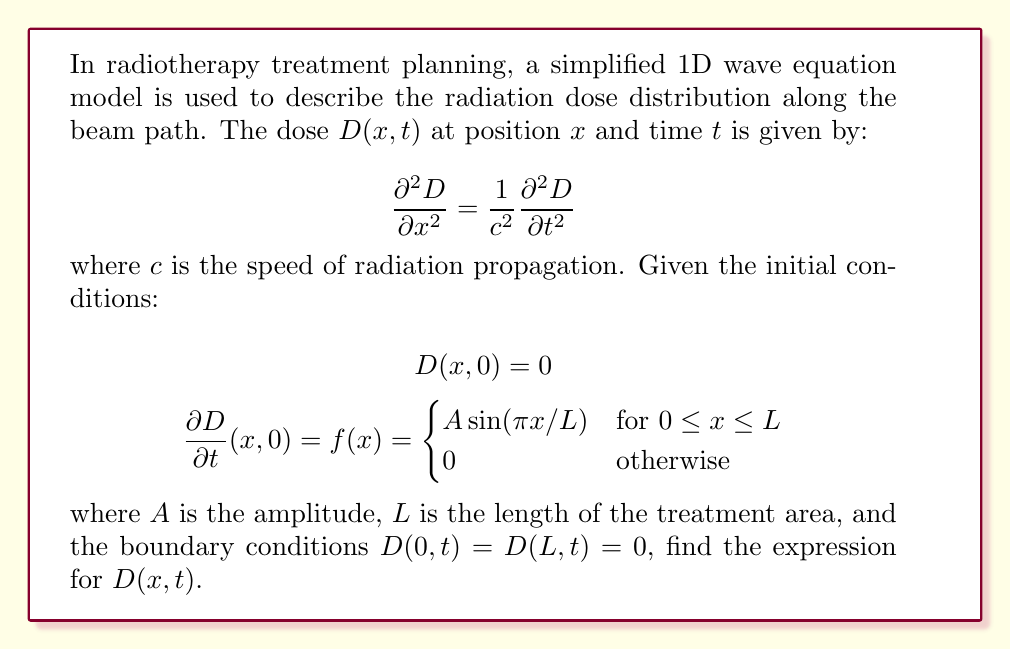Provide a solution to this math problem. To solve this wave equation with the given initial and boundary conditions, we'll follow these steps:

1) The general solution for the 1D wave equation is given by:

   $$D(x,t) = \sum_{n=1}^{\infty} [A_n \cos(n\pi ct/L) + B_n \sin(n\pi ct/L)] \sin(n\pi x/L)$$

2) The boundary conditions $D(0,t) = D(L,t) = 0$ are already satisfied by this form.

3) From the first initial condition $D(x,0) = 0$, we can deduce that $A_n = 0$ for all $n$.

4) Now we use the second initial condition:

   $$\frac{\partial D}{\partial t}(x,0) = \sum_{n=1}^{\infty} B_n \frac{n\pi c}{L} \sin(n\pi x/L) = f(x)$$

5) To find $B_n$, we use the Fourier sine series:

   $$B_n \frac{n\pi c}{L} = \frac{2}{L} \int_0^L f(x) \sin(n\pi x/L) dx$$

6) Substituting $f(x) = A\sin(\pi x/L)$:

   $$B_n \frac{n\pi c}{L} = \frac{2A}{L} \int_0^L \sin(\pi x/L) \sin(n\pi x/L) dx$$

7) This integral is zero for all $n \neq 1$, and for $n=1$:

   $$B_1 \frac{\pi c}{L} = \frac{2A}{L} \int_0^L \sin^2(\pi x/L) dx = \frac{2A}{L} \cdot \frac{L}{2} = A$$

8) Therefore, $B_1 = \frac{AL}{\pi c}$ and $B_n = 0$ for $n > 1$.

9) Substituting this back into the general solution:

   $$D(x,t) = \frac{AL}{\pi c} \sin(\pi ct/L) \sin(\pi x/L)$$

This is the final expression for the dose distribution $D(x,t)$.
Answer: $D(x,t) = \frac{AL}{\pi c} \sin(\pi ct/L) \sin(\pi x/L)$ 